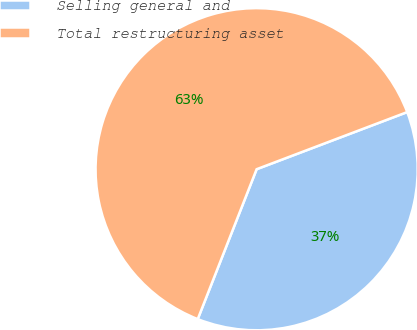<chart> <loc_0><loc_0><loc_500><loc_500><pie_chart><fcel>Selling general and<fcel>Total restructuring asset<nl><fcel>36.73%<fcel>63.27%<nl></chart> 